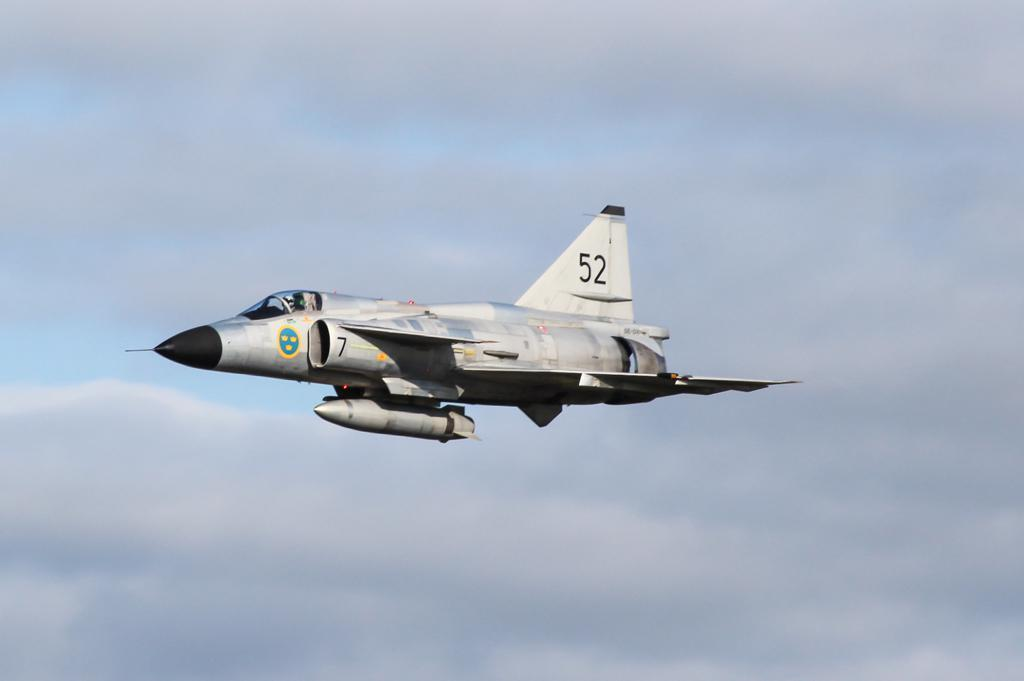<image>
Render a clear and concise summary of the photo. a silver military jet in the sky with 52 on the tail 